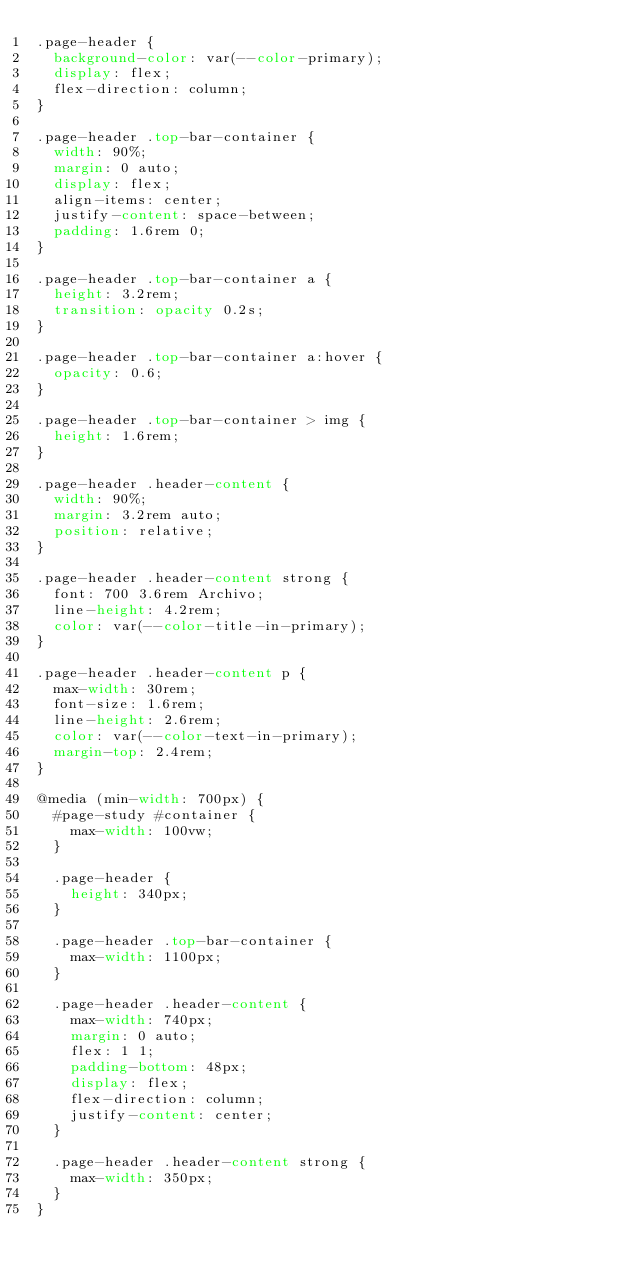<code> <loc_0><loc_0><loc_500><loc_500><_CSS_>.page-header {
	background-color: var(--color-primary);
	display: flex;
	flex-direction: column;
}

.page-header .top-bar-container {
	width: 90%;
	margin: 0 auto;
	display: flex;
	align-items: center;
	justify-content: space-between;
	padding: 1.6rem 0;
}

.page-header .top-bar-container a {
	height: 3.2rem;
	transition: opacity 0.2s;
}

.page-header .top-bar-container a:hover {
	opacity: 0.6;
}

.page-header .top-bar-container > img {
	height: 1.6rem;
}

.page-header .header-content {
	width: 90%;
	margin: 3.2rem auto;
	position: relative;
}

.page-header .header-content strong {
	font: 700 3.6rem Archivo;
	line-height: 4.2rem;
	color: var(--color-title-in-primary);
}

.page-header .header-content p {
	max-width: 30rem;
	font-size: 1.6rem;
	line-height: 2.6rem;
	color: var(--color-text-in-primary);
	margin-top: 2.4rem;
}

@media (min-width: 700px) {
	#page-study #container {
		max-width: 100vw;
	}

	.page-header {
		height: 340px;
	}

	.page-header .top-bar-container {
		max-width: 1100px;
	}

	.page-header .header-content {
		max-width: 740px;
		margin: 0 auto;
		flex: 1 1;
		padding-bottom: 48px;
		display: flex;
		flex-direction: column;
		justify-content: center;
	}

	.page-header .header-content strong {
		max-width: 350px;
	}
}</code> 